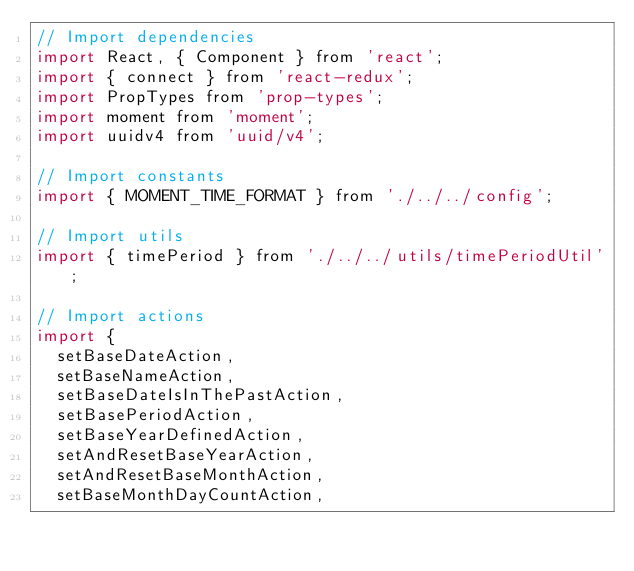<code> <loc_0><loc_0><loc_500><loc_500><_JavaScript_>// Import dependencies
import React, { Component } from 'react';
import { connect } from 'react-redux';
import PropTypes from 'prop-types';
import moment from 'moment';
import uuidv4 from 'uuid/v4';

// Import constants
import { MOMENT_TIME_FORMAT } from './../../config';

// Import utils
import { timePeriod } from './../../utils/timePeriodUtil';

// Import actions
import {
  setBaseDateAction,
  setBaseNameAction,
  setBaseDateIsInThePastAction,
  setBasePeriodAction,
  setBaseYearDefinedAction,
  setAndResetBaseYearAction,
  setAndResetBaseMonthAction,
  setBaseMonthDayCountAction,</code> 